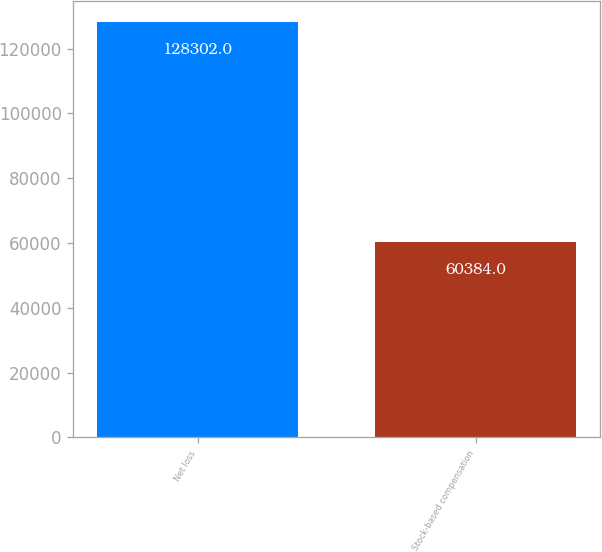Convert chart. <chart><loc_0><loc_0><loc_500><loc_500><bar_chart><fcel>Net loss<fcel>Stock-based compensation<nl><fcel>128302<fcel>60384<nl></chart> 